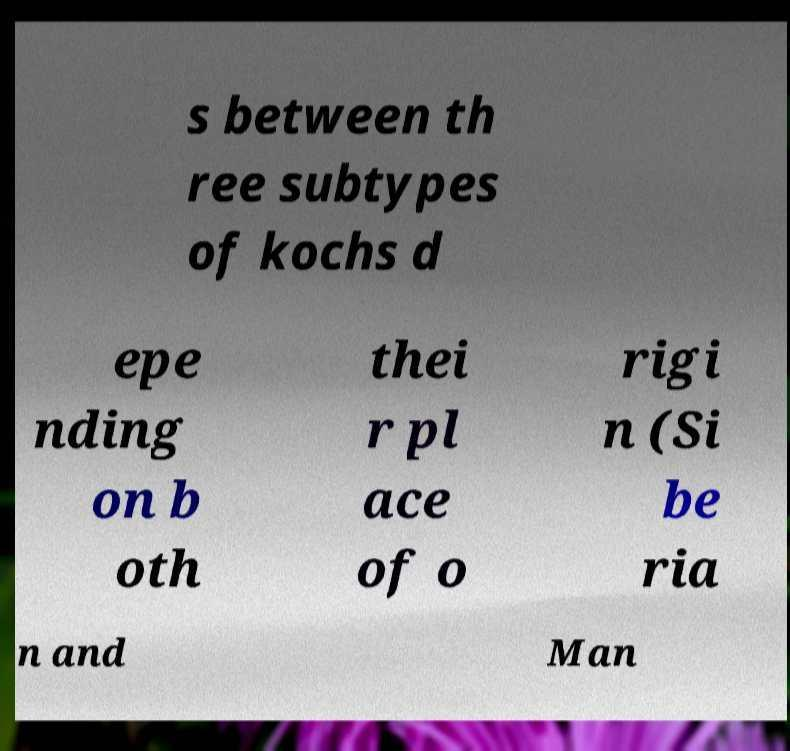Please identify and transcribe the text found in this image. s between th ree subtypes of kochs d epe nding on b oth thei r pl ace of o rigi n (Si be ria n and Man 